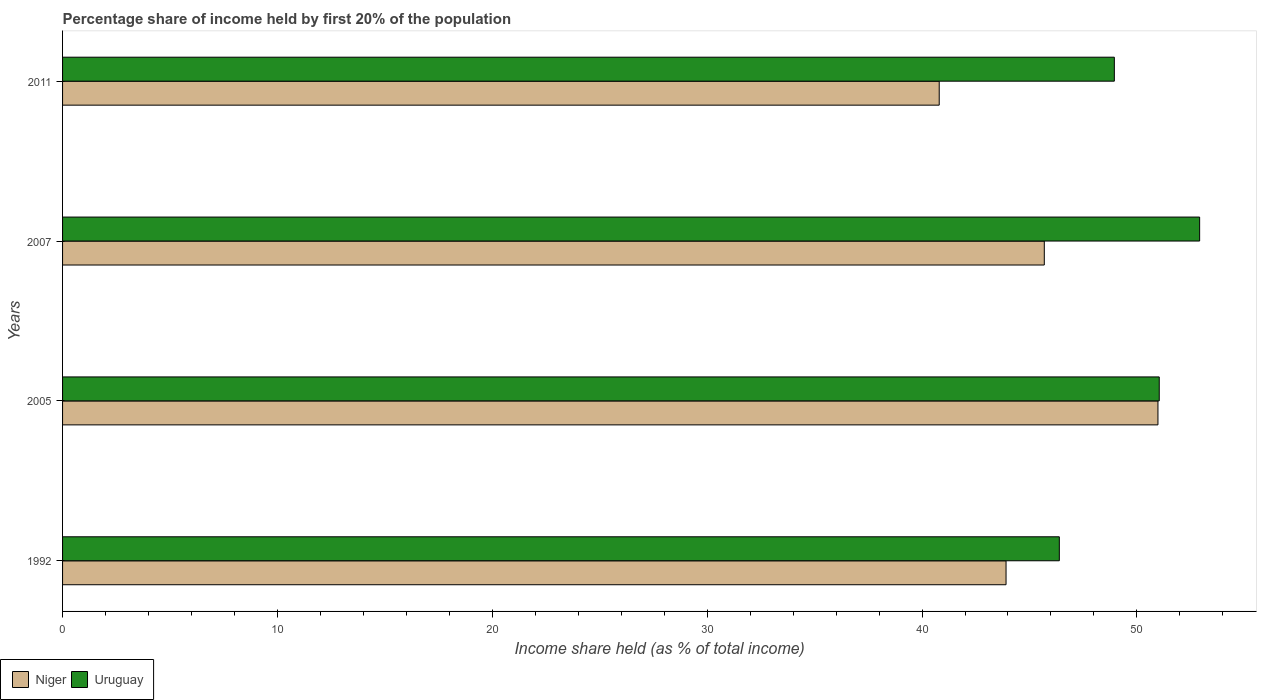How many different coloured bars are there?
Give a very brief answer. 2. Are the number of bars per tick equal to the number of legend labels?
Provide a succinct answer. Yes. How many bars are there on the 2nd tick from the top?
Offer a very short reply. 2. In how many cases, is the number of bars for a given year not equal to the number of legend labels?
Ensure brevity in your answer.  0. What is the share of income held by first 20% of the population in Uruguay in 2007?
Keep it short and to the point. 52.92. Across all years, what is the maximum share of income held by first 20% of the population in Niger?
Your response must be concise. 50.98. Across all years, what is the minimum share of income held by first 20% of the population in Uruguay?
Provide a succinct answer. 46.39. In which year was the share of income held by first 20% of the population in Niger maximum?
Your answer should be very brief. 2005. In which year was the share of income held by first 20% of the population in Uruguay minimum?
Offer a terse response. 1992. What is the total share of income held by first 20% of the population in Niger in the graph?
Provide a succinct answer. 181.38. What is the difference between the share of income held by first 20% of the population in Uruguay in 2007 and that in 2011?
Ensure brevity in your answer.  3.97. What is the difference between the share of income held by first 20% of the population in Niger in 2005 and the share of income held by first 20% of the population in Uruguay in 2011?
Provide a short and direct response. 2.03. What is the average share of income held by first 20% of the population in Niger per year?
Ensure brevity in your answer.  45.34. In the year 1992, what is the difference between the share of income held by first 20% of the population in Uruguay and share of income held by first 20% of the population in Niger?
Offer a very short reply. 2.48. What is the ratio of the share of income held by first 20% of the population in Uruguay in 1992 to that in 2011?
Your response must be concise. 0.95. Is the difference between the share of income held by first 20% of the population in Uruguay in 1992 and 2005 greater than the difference between the share of income held by first 20% of the population in Niger in 1992 and 2005?
Make the answer very short. Yes. What is the difference between the highest and the second highest share of income held by first 20% of the population in Niger?
Provide a succinct answer. 5.29. What is the difference between the highest and the lowest share of income held by first 20% of the population in Niger?
Your answer should be compact. 10.18. In how many years, is the share of income held by first 20% of the population in Uruguay greater than the average share of income held by first 20% of the population in Uruguay taken over all years?
Make the answer very short. 2. What does the 1st bar from the top in 1992 represents?
Your answer should be compact. Uruguay. What does the 1st bar from the bottom in 2007 represents?
Ensure brevity in your answer.  Niger. How many bars are there?
Offer a very short reply. 8. Does the graph contain any zero values?
Your answer should be very brief. No. Does the graph contain grids?
Your answer should be very brief. No. Where does the legend appear in the graph?
Offer a very short reply. Bottom left. How many legend labels are there?
Provide a succinct answer. 2. What is the title of the graph?
Provide a succinct answer. Percentage share of income held by first 20% of the population. What is the label or title of the X-axis?
Offer a terse response. Income share held (as % of total income). What is the Income share held (as % of total income) in Niger in 1992?
Your answer should be compact. 43.91. What is the Income share held (as % of total income) in Uruguay in 1992?
Provide a succinct answer. 46.39. What is the Income share held (as % of total income) of Niger in 2005?
Provide a succinct answer. 50.98. What is the Income share held (as % of total income) in Uruguay in 2005?
Your answer should be compact. 51.04. What is the Income share held (as % of total income) of Niger in 2007?
Offer a terse response. 45.69. What is the Income share held (as % of total income) of Uruguay in 2007?
Make the answer very short. 52.92. What is the Income share held (as % of total income) of Niger in 2011?
Your response must be concise. 40.8. What is the Income share held (as % of total income) in Uruguay in 2011?
Your answer should be very brief. 48.95. Across all years, what is the maximum Income share held (as % of total income) of Niger?
Your answer should be very brief. 50.98. Across all years, what is the maximum Income share held (as % of total income) in Uruguay?
Offer a terse response. 52.92. Across all years, what is the minimum Income share held (as % of total income) of Niger?
Provide a short and direct response. 40.8. Across all years, what is the minimum Income share held (as % of total income) in Uruguay?
Keep it short and to the point. 46.39. What is the total Income share held (as % of total income) in Niger in the graph?
Make the answer very short. 181.38. What is the total Income share held (as % of total income) in Uruguay in the graph?
Your response must be concise. 199.3. What is the difference between the Income share held (as % of total income) of Niger in 1992 and that in 2005?
Offer a very short reply. -7.07. What is the difference between the Income share held (as % of total income) in Uruguay in 1992 and that in 2005?
Your response must be concise. -4.65. What is the difference between the Income share held (as % of total income) of Niger in 1992 and that in 2007?
Provide a short and direct response. -1.78. What is the difference between the Income share held (as % of total income) in Uruguay in 1992 and that in 2007?
Your answer should be very brief. -6.53. What is the difference between the Income share held (as % of total income) in Niger in 1992 and that in 2011?
Your answer should be compact. 3.11. What is the difference between the Income share held (as % of total income) in Uruguay in 1992 and that in 2011?
Ensure brevity in your answer.  -2.56. What is the difference between the Income share held (as % of total income) of Niger in 2005 and that in 2007?
Your response must be concise. 5.29. What is the difference between the Income share held (as % of total income) of Uruguay in 2005 and that in 2007?
Provide a succinct answer. -1.88. What is the difference between the Income share held (as % of total income) of Niger in 2005 and that in 2011?
Give a very brief answer. 10.18. What is the difference between the Income share held (as % of total income) in Uruguay in 2005 and that in 2011?
Ensure brevity in your answer.  2.09. What is the difference between the Income share held (as % of total income) in Niger in 2007 and that in 2011?
Offer a very short reply. 4.89. What is the difference between the Income share held (as % of total income) of Uruguay in 2007 and that in 2011?
Your answer should be very brief. 3.97. What is the difference between the Income share held (as % of total income) of Niger in 1992 and the Income share held (as % of total income) of Uruguay in 2005?
Your answer should be very brief. -7.13. What is the difference between the Income share held (as % of total income) of Niger in 1992 and the Income share held (as % of total income) of Uruguay in 2007?
Your answer should be very brief. -9.01. What is the difference between the Income share held (as % of total income) in Niger in 1992 and the Income share held (as % of total income) in Uruguay in 2011?
Keep it short and to the point. -5.04. What is the difference between the Income share held (as % of total income) in Niger in 2005 and the Income share held (as % of total income) in Uruguay in 2007?
Your answer should be compact. -1.94. What is the difference between the Income share held (as % of total income) in Niger in 2005 and the Income share held (as % of total income) in Uruguay in 2011?
Make the answer very short. 2.03. What is the difference between the Income share held (as % of total income) of Niger in 2007 and the Income share held (as % of total income) of Uruguay in 2011?
Provide a short and direct response. -3.26. What is the average Income share held (as % of total income) of Niger per year?
Your answer should be very brief. 45.34. What is the average Income share held (as % of total income) in Uruguay per year?
Offer a very short reply. 49.83. In the year 1992, what is the difference between the Income share held (as % of total income) in Niger and Income share held (as % of total income) in Uruguay?
Offer a very short reply. -2.48. In the year 2005, what is the difference between the Income share held (as % of total income) in Niger and Income share held (as % of total income) in Uruguay?
Offer a very short reply. -0.06. In the year 2007, what is the difference between the Income share held (as % of total income) in Niger and Income share held (as % of total income) in Uruguay?
Your response must be concise. -7.23. In the year 2011, what is the difference between the Income share held (as % of total income) of Niger and Income share held (as % of total income) of Uruguay?
Provide a succinct answer. -8.15. What is the ratio of the Income share held (as % of total income) of Niger in 1992 to that in 2005?
Offer a terse response. 0.86. What is the ratio of the Income share held (as % of total income) in Uruguay in 1992 to that in 2005?
Offer a very short reply. 0.91. What is the ratio of the Income share held (as % of total income) of Uruguay in 1992 to that in 2007?
Make the answer very short. 0.88. What is the ratio of the Income share held (as % of total income) in Niger in 1992 to that in 2011?
Provide a short and direct response. 1.08. What is the ratio of the Income share held (as % of total income) of Uruguay in 1992 to that in 2011?
Provide a succinct answer. 0.95. What is the ratio of the Income share held (as % of total income) of Niger in 2005 to that in 2007?
Your response must be concise. 1.12. What is the ratio of the Income share held (as % of total income) in Uruguay in 2005 to that in 2007?
Your response must be concise. 0.96. What is the ratio of the Income share held (as % of total income) in Niger in 2005 to that in 2011?
Provide a short and direct response. 1.25. What is the ratio of the Income share held (as % of total income) in Uruguay in 2005 to that in 2011?
Your answer should be very brief. 1.04. What is the ratio of the Income share held (as % of total income) of Niger in 2007 to that in 2011?
Provide a succinct answer. 1.12. What is the ratio of the Income share held (as % of total income) in Uruguay in 2007 to that in 2011?
Make the answer very short. 1.08. What is the difference between the highest and the second highest Income share held (as % of total income) in Niger?
Offer a terse response. 5.29. What is the difference between the highest and the second highest Income share held (as % of total income) in Uruguay?
Keep it short and to the point. 1.88. What is the difference between the highest and the lowest Income share held (as % of total income) of Niger?
Your response must be concise. 10.18. What is the difference between the highest and the lowest Income share held (as % of total income) of Uruguay?
Offer a very short reply. 6.53. 